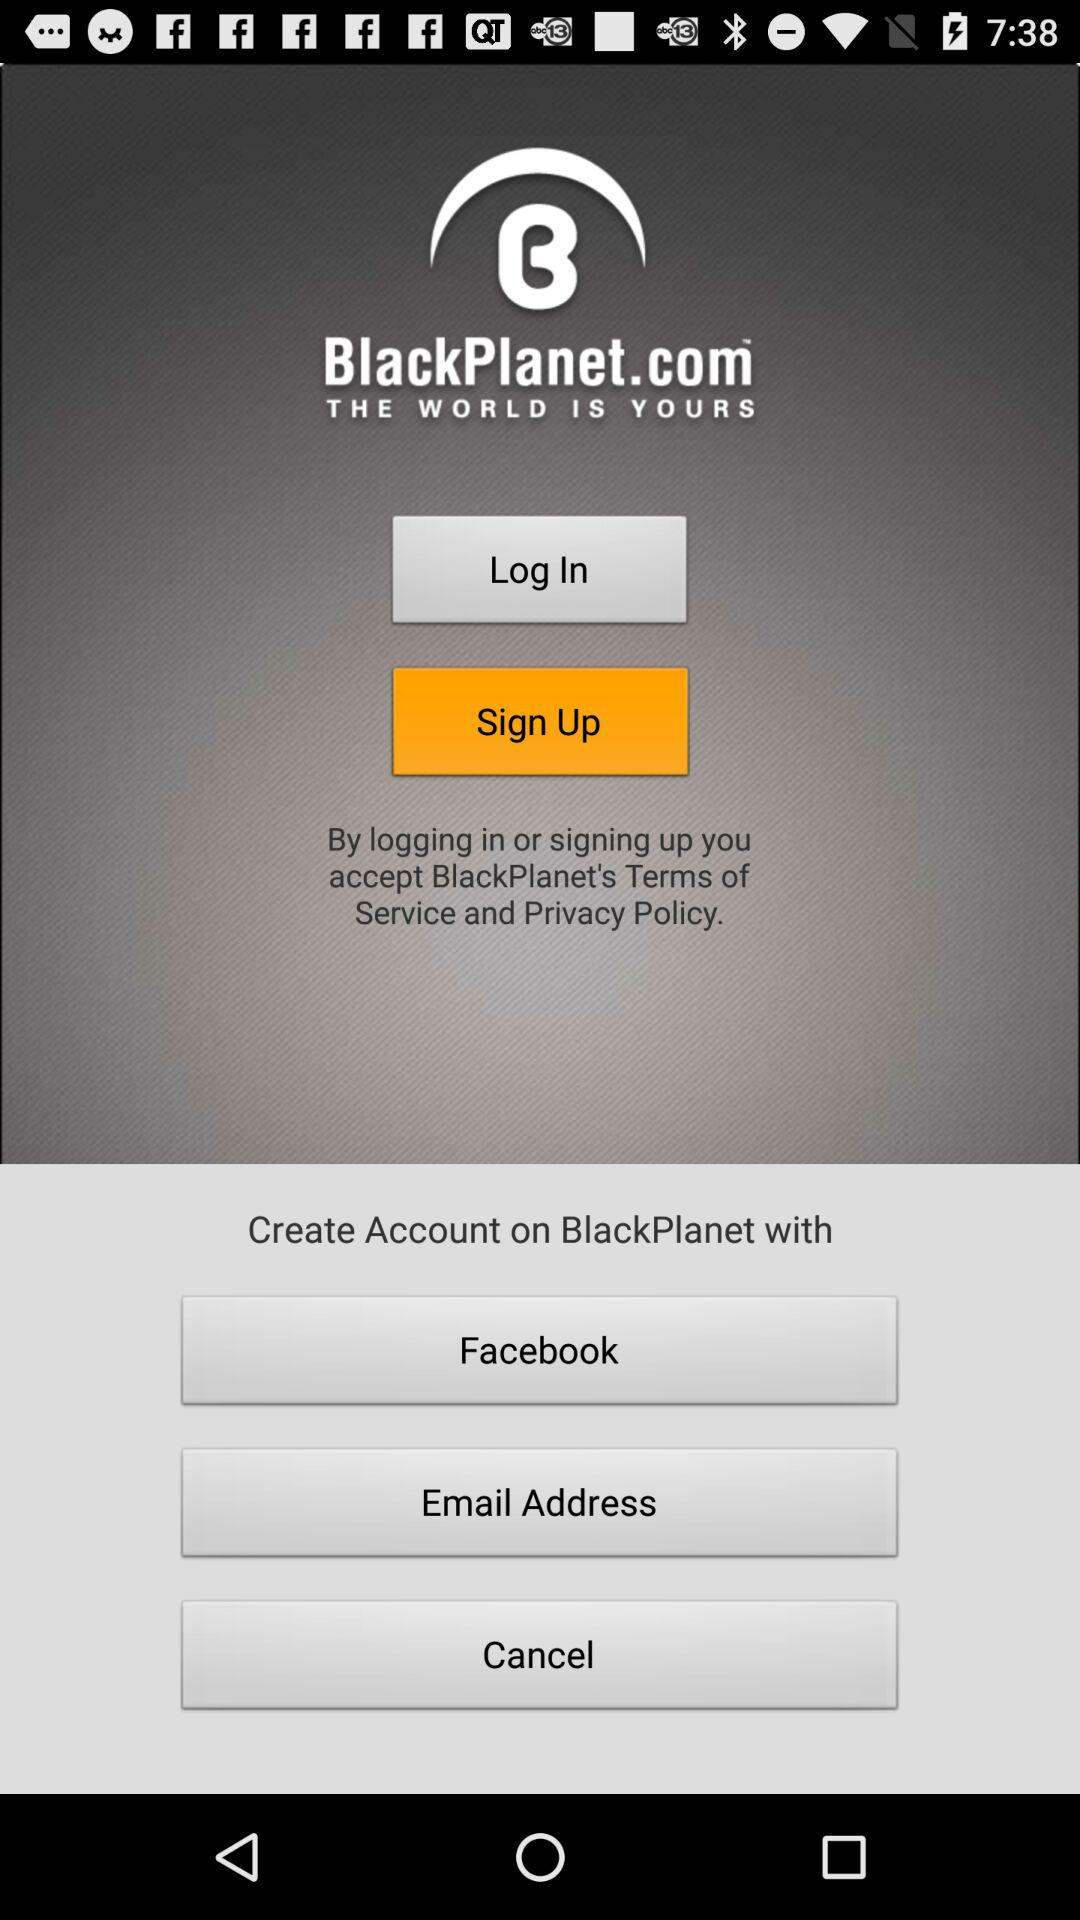Through which account can a user create a "BlackPlanet" account? Through "Facebook" and "Email" accounts, a user can create a "BlackPlanet" account. 